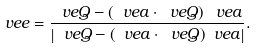<formula> <loc_0><loc_0><loc_500><loc_500>\ v e { e } = \frac { \ v e { Q } - \left ( \ v e { a } \cdot \ v e { Q } \right ) \ v e { a } } { \left | \ v e { Q } - ( \ v e { a } \cdot \ v e { Q } ) \ v e { a } \right | } .</formula> 